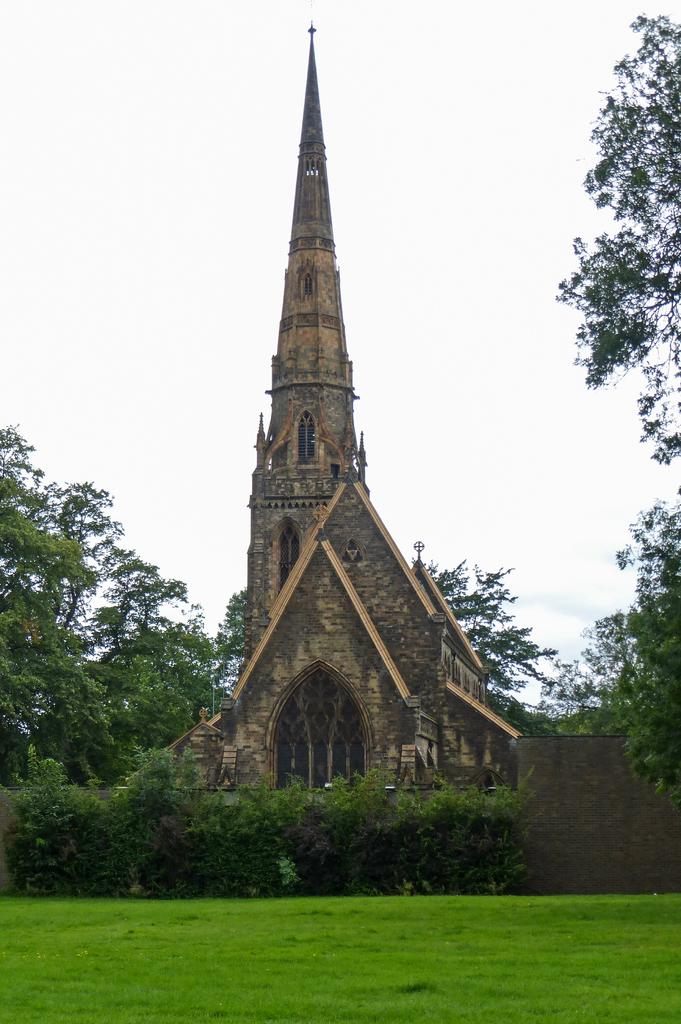What type of building is in the image? There is a church in the image. What is a notable feature of the church? The church has a tall steeple. What is in front of the church? There is a wall in front of the church. What type of vegetation can be seen in the image? There are trees, bushes, and plants in the image. What is the ground covered with in the image? There is grass on the ground in the image. What is visible at the top of the image? The sky is visible at the top of the image. Can you see any fowl or horses in the image? No, there are no fowl or horses present in the image. Are there any people kissing in the image? No, there are no people kissing in the image. 